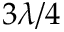Convert formula to latex. <formula><loc_0><loc_0><loc_500><loc_500>3 \lambda / 4</formula> 